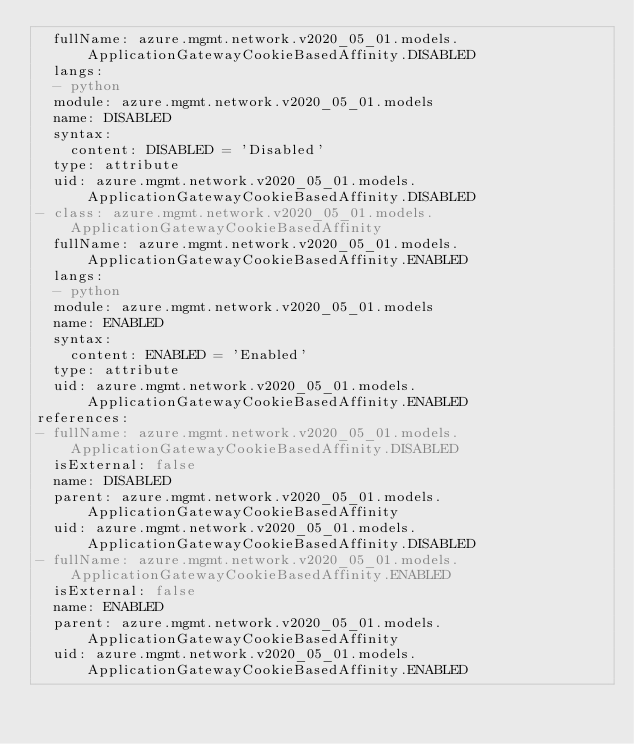Convert code to text. <code><loc_0><loc_0><loc_500><loc_500><_YAML_>  fullName: azure.mgmt.network.v2020_05_01.models.ApplicationGatewayCookieBasedAffinity.DISABLED
  langs:
  - python
  module: azure.mgmt.network.v2020_05_01.models
  name: DISABLED
  syntax:
    content: DISABLED = 'Disabled'
  type: attribute
  uid: azure.mgmt.network.v2020_05_01.models.ApplicationGatewayCookieBasedAffinity.DISABLED
- class: azure.mgmt.network.v2020_05_01.models.ApplicationGatewayCookieBasedAffinity
  fullName: azure.mgmt.network.v2020_05_01.models.ApplicationGatewayCookieBasedAffinity.ENABLED
  langs:
  - python
  module: azure.mgmt.network.v2020_05_01.models
  name: ENABLED
  syntax:
    content: ENABLED = 'Enabled'
  type: attribute
  uid: azure.mgmt.network.v2020_05_01.models.ApplicationGatewayCookieBasedAffinity.ENABLED
references:
- fullName: azure.mgmt.network.v2020_05_01.models.ApplicationGatewayCookieBasedAffinity.DISABLED
  isExternal: false
  name: DISABLED
  parent: azure.mgmt.network.v2020_05_01.models.ApplicationGatewayCookieBasedAffinity
  uid: azure.mgmt.network.v2020_05_01.models.ApplicationGatewayCookieBasedAffinity.DISABLED
- fullName: azure.mgmt.network.v2020_05_01.models.ApplicationGatewayCookieBasedAffinity.ENABLED
  isExternal: false
  name: ENABLED
  parent: azure.mgmt.network.v2020_05_01.models.ApplicationGatewayCookieBasedAffinity
  uid: azure.mgmt.network.v2020_05_01.models.ApplicationGatewayCookieBasedAffinity.ENABLED
</code> 